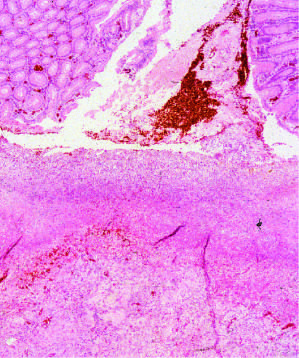what is composed of granulation tissue overlaid by degraded blood?
Answer the question using a single word or phrase. The necrotic ulcer base 